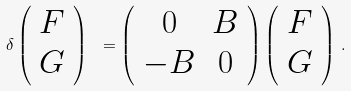<formula> <loc_0><loc_0><loc_500><loc_500>\delta \left ( \begin{array} { c c } F \\ G \\ \end{array} \right ) \ = \left ( \begin{array} { c c } 0 & B \\ - B & 0 \\ \end{array} \right ) \left ( \begin{array} { c c } F \\ G \\ \end{array} \right ) \, .</formula> 